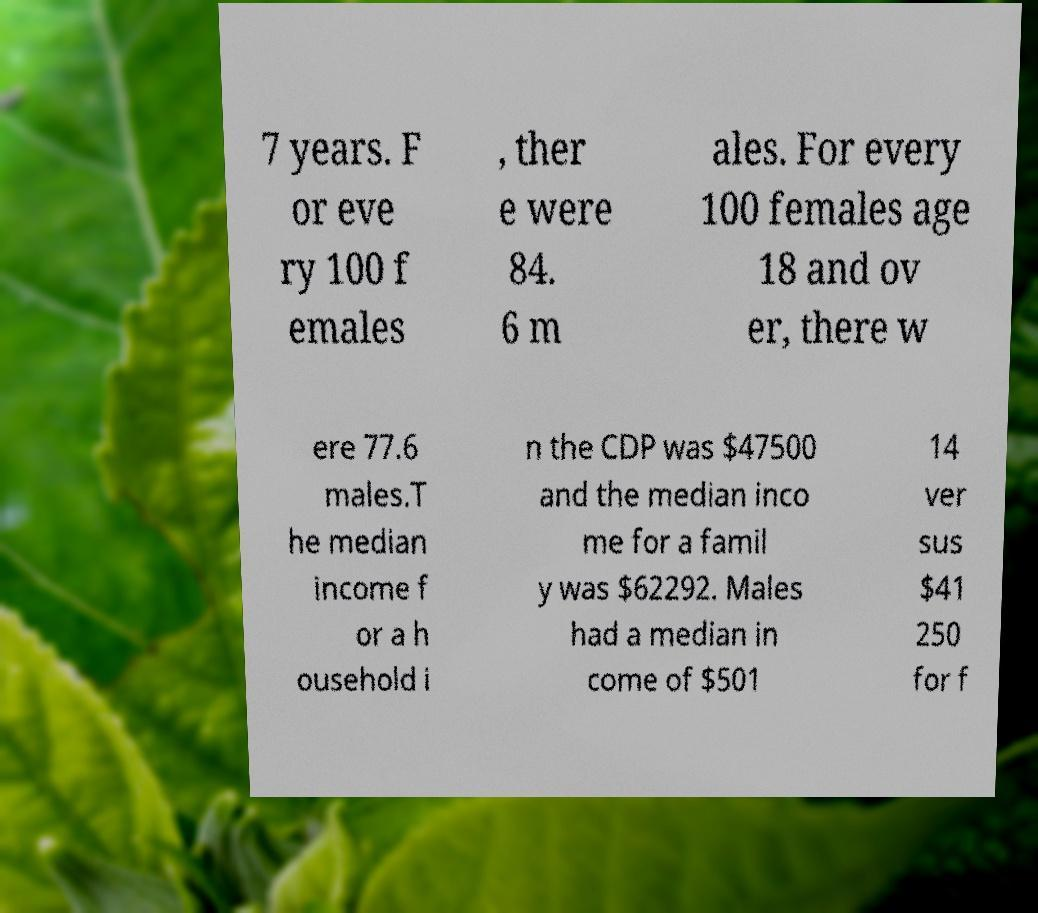Could you assist in decoding the text presented in this image and type it out clearly? 7 years. F or eve ry 100 f emales , ther e were 84. 6 m ales. For every 100 females age 18 and ov er, there w ere 77.6 males.T he median income f or a h ousehold i n the CDP was $47500 and the median inco me for a famil y was $62292. Males had a median in come of $501 14 ver sus $41 250 for f 